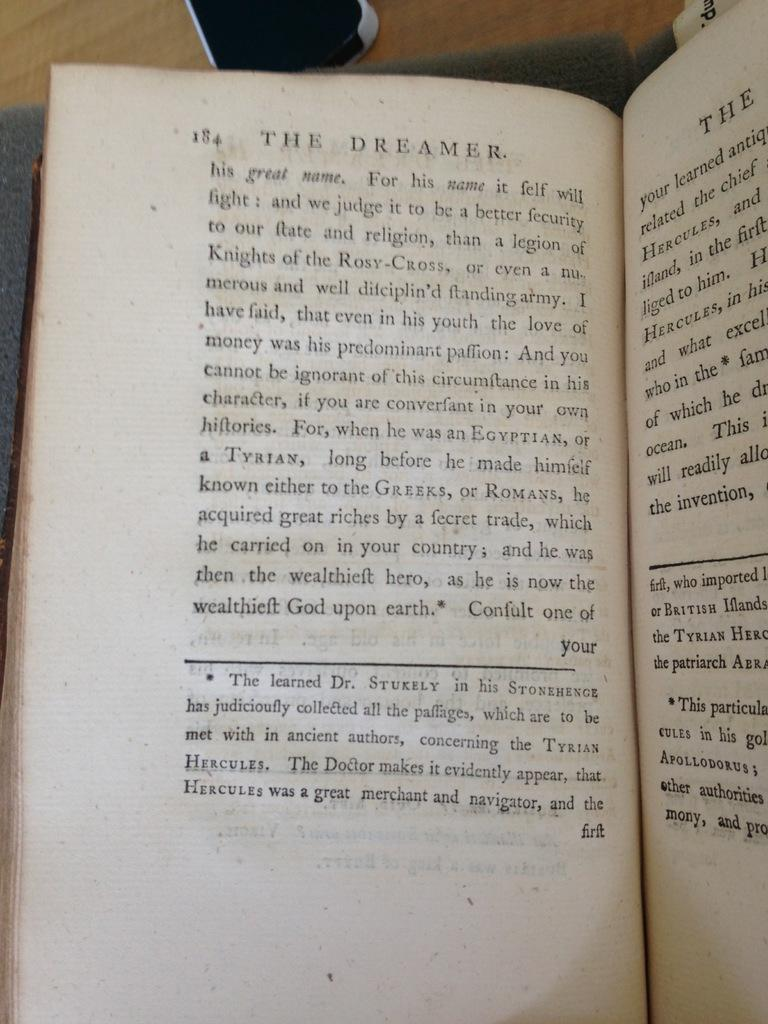<image>
Create a compact narrative representing the image presented. A book titled The Dreamer is open to page 184 